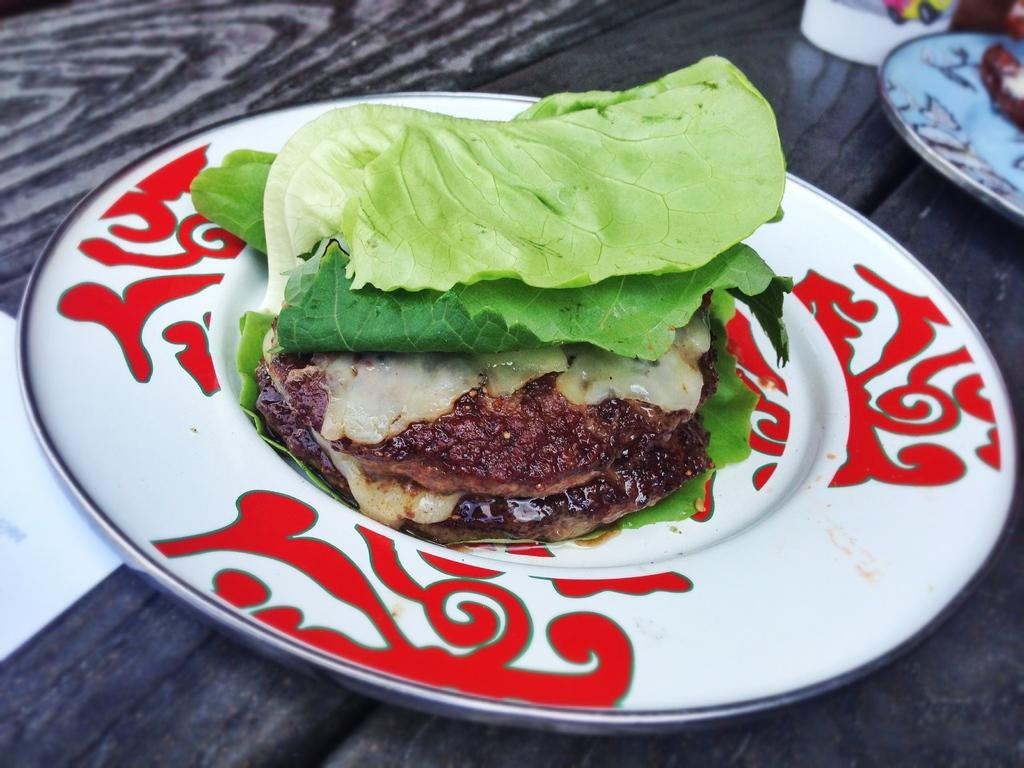What is on the plate that is visible in the image? There are food items on a plate in the image. Where is the plate located in the image? The plate is on a table in the image. What else can be seen on the table besides the plate? There are other objects on the table in the image. Can you see a map on the plate in the image? No, there is no map present on the plate in the image. 